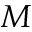<formula> <loc_0><loc_0><loc_500><loc_500>M</formula> 